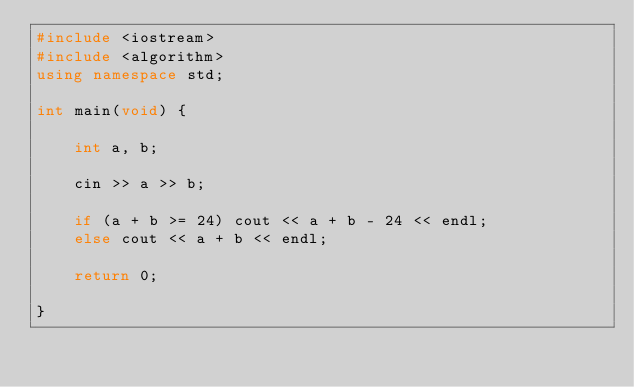Convert code to text. <code><loc_0><loc_0><loc_500><loc_500><_C++_>#include <iostream>
#include <algorithm>
using namespace std;

int main(void) {

	int a, b;

	cin >> a >> b;

	if (a + b >= 24) cout << a + b - 24 << endl;
	else cout << a + b << endl;

	return 0;

}</code> 